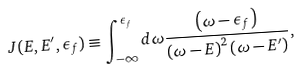Convert formula to latex. <formula><loc_0><loc_0><loc_500><loc_500>J ( E , E ^ { \prime } , \epsilon _ { f } ) \equiv \int _ { - \infty } ^ { \epsilon _ { f } } d \omega \frac { \left ( \omega - \epsilon _ { f } \right ) } { \left ( \omega - E \right ) ^ { 2 } \left ( \omega - E ^ { \prime } \right ) } ,</formula> 